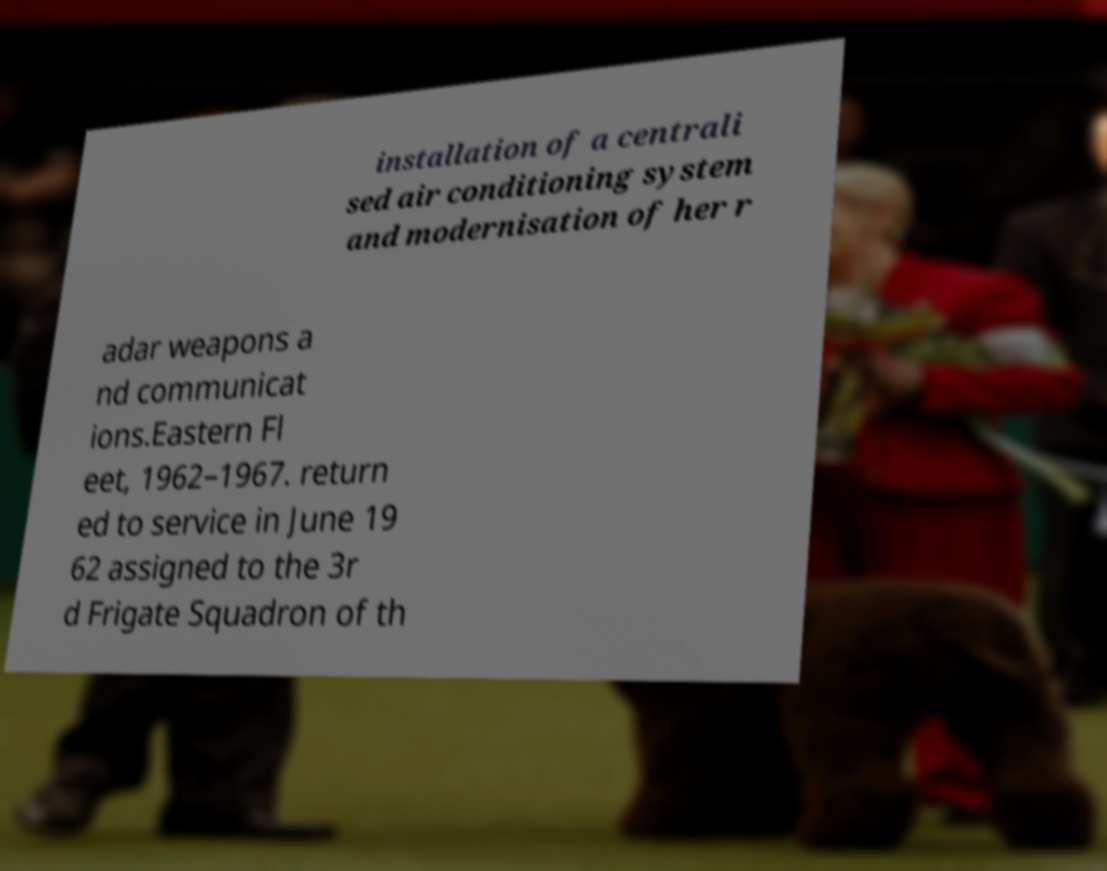Could you assist in decoding the text presented in this image and type it out clearly? installation of a centrali sed air conditioning system and modernisation of her r adar weapons a nd communicat ions.Eastern Fl eet, 1962–1967. return ed to service in June 19 62 assigned to the 3r d Frigate Squadron of th 